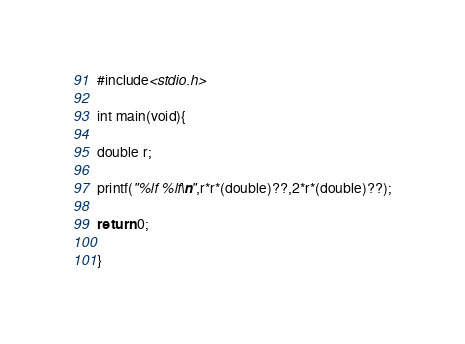<code> <loc_0><loc_0><loc_500><loc_500><_C_>#include<stdio.h>

int main(void){

double r;

printf("%lf %lf\n",r*r*(double)??,2*r*(double)??);

return 0;

}</code> 